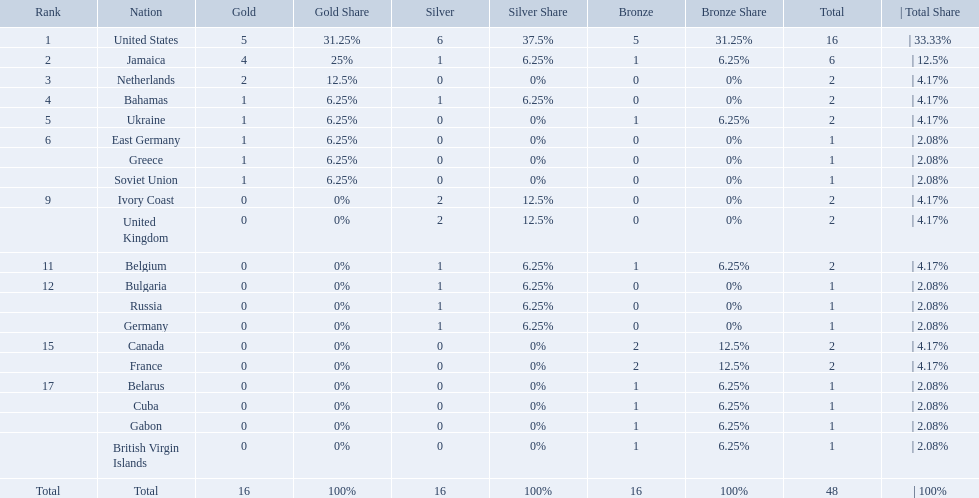Can you parse all the data within this table? {'header': ['Rank', 'Nation', 'Gold', 'Gold Share', 'Silver', 'Silver Share', 'Bronze', 'Bronze Share', 'Total', '| Total Share'], 'rows': [['1', 'United States', '5', '31.25%', '6', '37.5%', '5', '31.25%', '16', '| 33.33%'], ['2', 'Jamaica', '4', '25%', '1', '6.25%', '1', '6.25%', '6', '| 12.5%'], ['3', 'Netherlands', '2', '12.5%', '0', '0%', '0', '0%', '2', '| 4.17%'], ['4', 'Bahamas', '1', '6.25%', '1', '6.25%', '0', '0%', '2', '| 4.17%'], ['5', 'Ukraine', '1', '6.25%', '0', '0%', '1', '6.25%', '2', '| 4.17%'], ['6', 'East Germany', '1', '6.25%', '0', '0%', '0', '0%', '1', '| 2.08%'], ['', 'Greece', '1', '6.25%', '0', '0%', '0', '0%', '1', '| 2.08%'], ['', 'Soviet Union', '1', '6.25%', '0', '0%', '0', '0%', '1', '| 2.08%'], ['9', 'Ivory Coast', '0', '0%', '2', '12.5%', '0', '0%', '2', '| 4.17%'], ['', 'United Kingdom', '0', '0%', '2', '12.5%', '0', '0%', '2', '| 4.17%'], ['11', 'Belgium', '0', '0%', '1', '6.25%', '1', '6.25%', '2', '| 4.17%'], ['12', 'Bulgaria', '0', '0%', '1', '6.25%', '0', '0%', '1', '| 2.08%'], ['', 'Russia', '0', '0%', '1', '6.25%', '0', '0%', '1', '| 2.08%'], ['', 'Germany', '0', '0%', '1', '6.25%', '0', '0%', '1', '| 2.08%'], ['15', 'Canada', '0', '0%', '0', '0%', '2', '12.5%', '2', '| 4.17%'], ['', 'France', '0', '0%', '0', '0%', '2', '12.5%', '2', '| 4.17%'], ['17', 'Belarus', '0', '0%', '0', '0%', '1', '6.25%', '1', '| 2.08%'], ['', 'Cuba', '0', '0%', '0', '0%', '1', '6.25%', '1', '| 2.08%'], ['', 'Gabon', '0', '0%', '0', '0%', '1', '6.25%', '1', '| 2.08%'], ['', 'British Virgin Islands', '0', '0%', '0', '0%', '1', '6.25%', '1', '| 2.08%'], ['Total', 'Total', '16', '100%', '16', '100%', '16', '100%', '48', '| 100%']]} Which countries competed in the 60 meters competition? United States, Jamaica, Netherlands, Bahamas, Ukraine, East Germany, Greece, Soviet Union, Ivory Coast, United Kingdom, Belgium, Bulgaria, Russia, Germany, Canada, France, Belarus, Cuba, Gabon, British Virgin Islands. And how many gold medals did they win? 5, 4, 2, 1, 1, 1, 1, 1, 0, 0, 0, 0, 0, 0, 0, 0, 0, 0, 0, 0. Of those countries, which won the second highest number gold medals? Jamaica. 